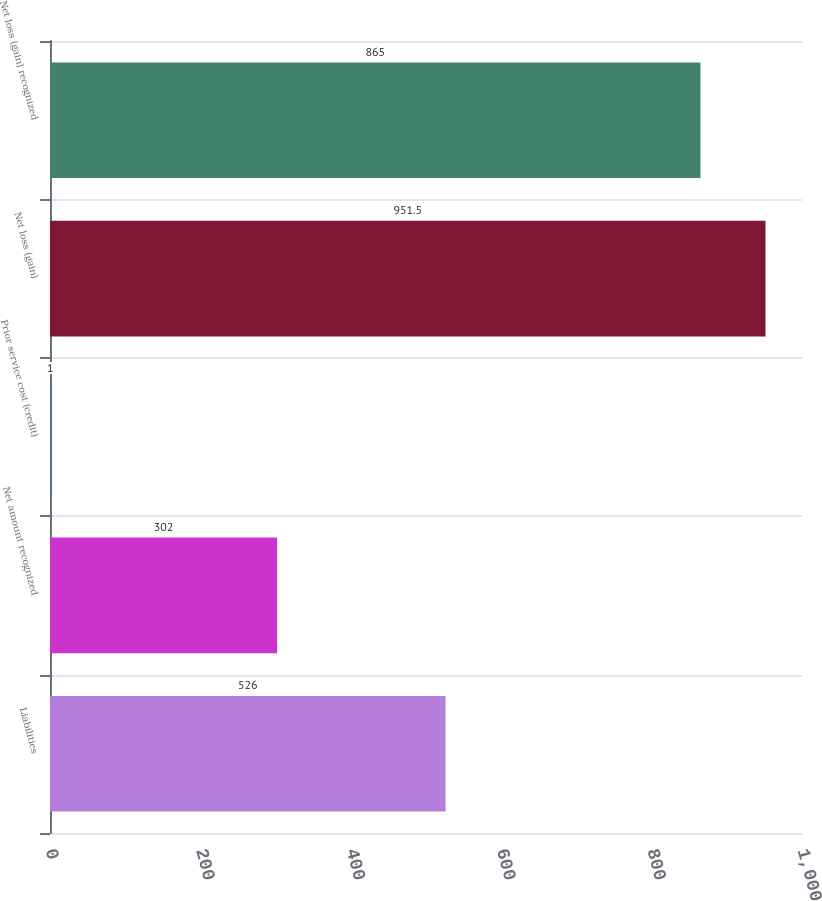Convert chart. <chart><loc_0><loc_0><loc_500><loc_500><bar_chart><fcel>Liabilities<fcel>Net amount recognized<fcel>Prior service cost (credit)<fcel>Net loss (gain)<fcel>Net loss (gain) recognized<nl><fcel>526<fcel>302<fcel>1<fcel>951.5<fcel>865<nl></chart> 